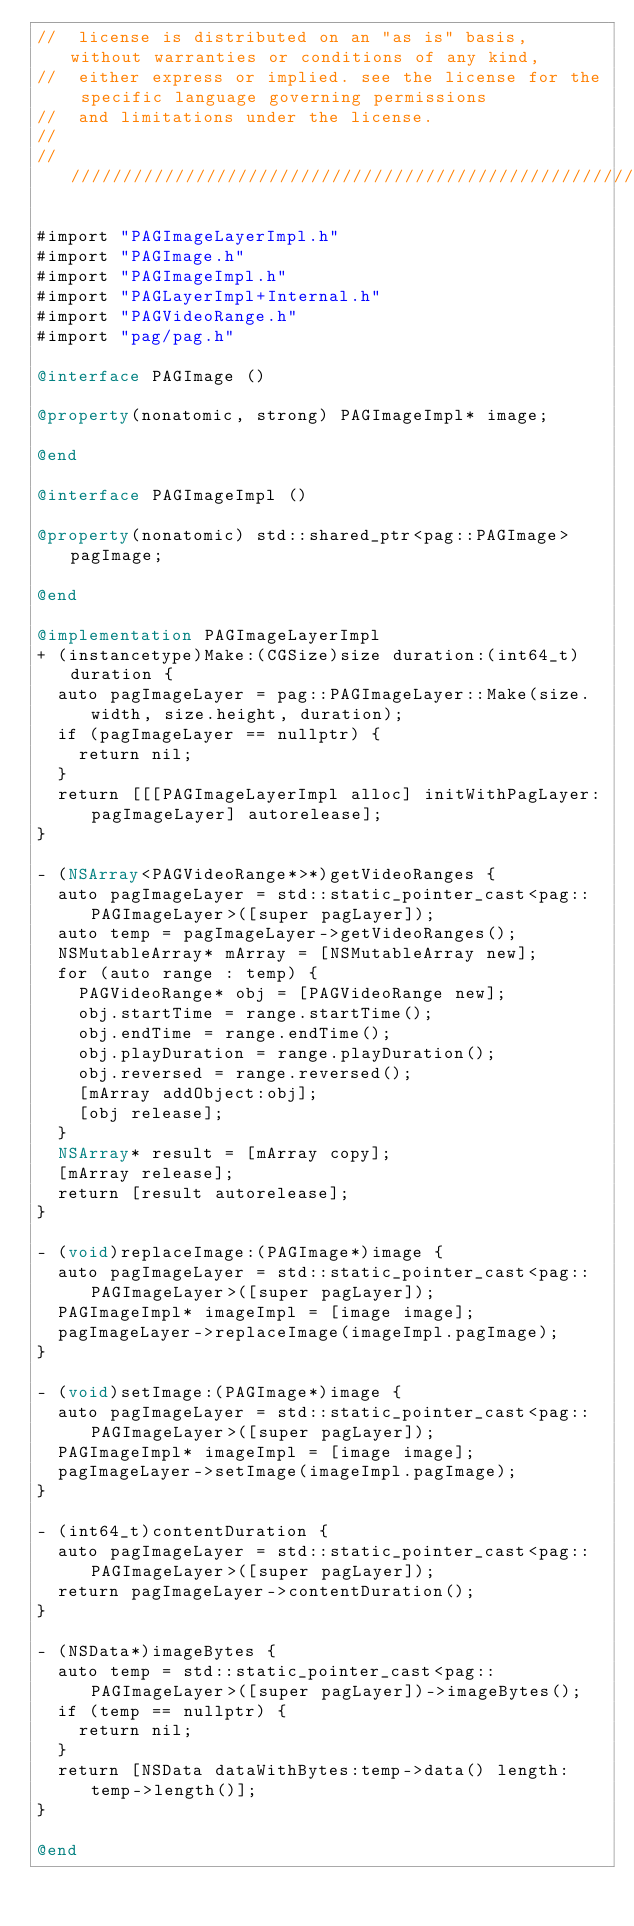<code> <loc_0><loc_0><loc_500><loc_500><_ObjectiveC_>//  license is distributed on an "as is" basis, without warranties or conditions of any kind,
//  either express or implied. see the license for the specific language governing permissions
//  and limitations under the license.
//
/////////////////////////////////////////////////////////////////////////////////////////////////

#import "PAGImageLayerImpl.h"
#import "PAGImage.h"
#import "PAGImageImpl.h"
#import "PAGLayerImpl+Internal.h"
#import "PAGVideoRange.h"
#import "pag/pag.h"

@interface PAGImage ()

@property(nonatomic, strong) PAGImageImpl* image;

@end

@interface PAGImageImpl ()

@property(nonatomic) std::shared_ptr<pag::PAGImage> pagImage;

@end

@implementation PAGImageLayerImpl
+ (instancetype)Make:(CGSize)size duration:(int64_t)duration {
  auto pagImageLayer = pag::PAGImageLayer::Make(size.width, size.height, duration);
  if (pagImageLayer == nullptr) {
    return nil;
  }
  return [[[PAGImageLayerImpl alloc] initWithPagLayer:pagImageLayer] autorelease];
}

- (NSArray<PAGVideoRange*>*)getVideoRanges {
  auto pagImageLayer = std::static_pointer_cast<pag::PAGImageLayer>([super pagLayer]);
  auto temp = pagImageLayer->getVideoRanges();
  NSMutableArray* mArray = [NSMutableArray new];
  for (auto range : temp) {
    PAGVideoRange* obj = [PAGVideoRange new];
    obj.startTime = range.startTime();
    obj.endTime = range.endTime();
    obj.playDuration = range.playDuration();
    obj.reversed = range.reversed();
    [mArray addObject:obj];
    [obj release];
  }
  NSArray* result = [mArray copy];
  [mArray release];
  return [result autorelease];
}

- (void)replaceImage:(PAGImage*)image {
  auto pagImageLayer = std::static_pointer_cast<pag::PAGImageLayer>([super pagLayer]);
  PAGImageImpl* imageImpl = [image image];
  pagImageLayer->replaceImage(imageImpl.pagImage);
}

- (void)setImage:(PAGImage*)image {
  auto pagImageLayer = std::static_pointer_cast<pag::PAGImageLayer>([super pagLayer]);
  PAGImageImpl* imageImpl = [image image];
  pagImageLayer->setImage(imageImpl.pagImage);
}

- (int64_t)contentDuration {
  auto pagImageLayer = std::static_pointer_cast<pag::PAGImageLayer>([super pagLayer]);
  return pagImageLayer->contentDuration();
}

- (NSData*)imageBytes {
  auto temp = std::static_pointer_cast<pag::PAGImageLayer>([super pagLayer])->imageBytes();
  if (temp == nullptr) {
    return nil;
  }
  return [NSData dataWithBytes:temp->data() length:temp->length()];
}

@end
</code> 